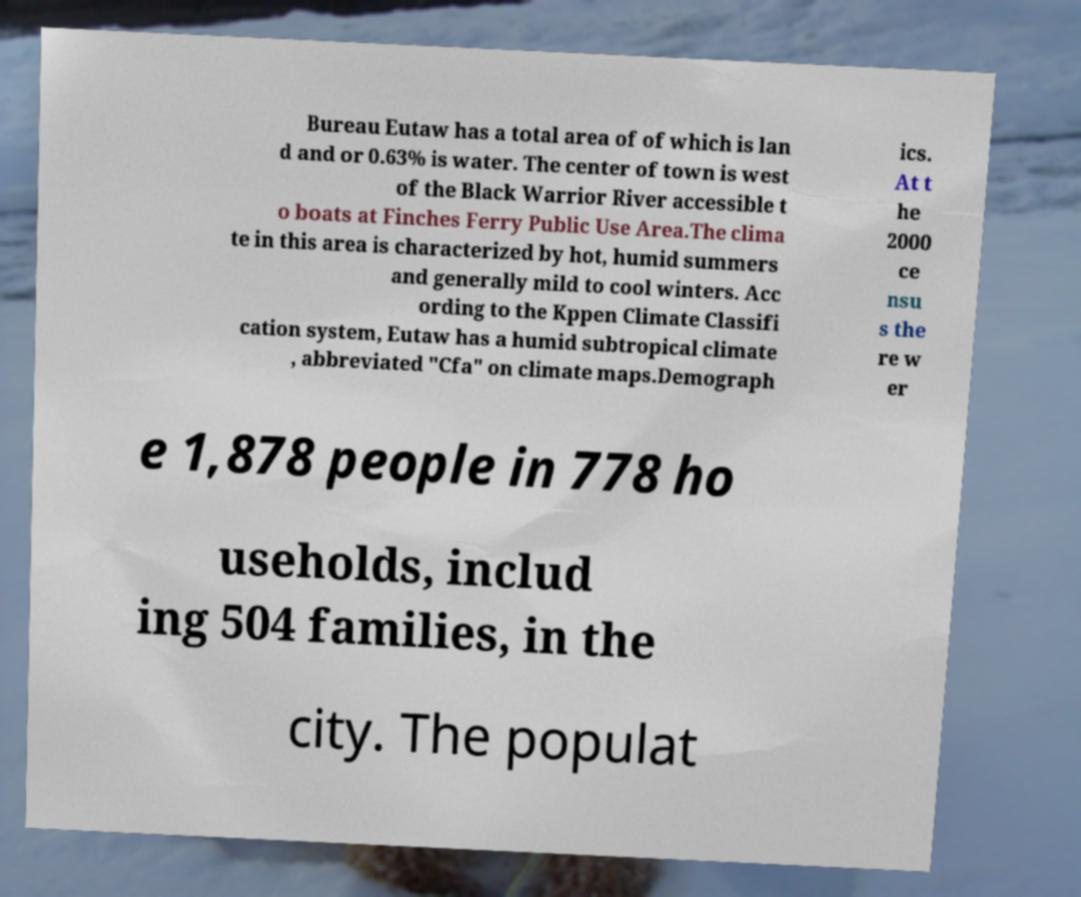There's text embedded in this image that I need extracted. Can you transcribe it verbatim? Bureau Eutaw has a total area of of which is lan d and or 0.63% is water. The center of town is west of the Black Warrior River accessible t o boats at Finches Ferry Public Use Area.The clima te in this area is characterized by hot, humid summers and generally mild to cool winters. Acc ording to the Kppen Climate Classifi cation system, Eutaw has a humid subtropical climate , abbreviated "Cfa" on climate maps.Demograph ics. At t he 2000 ce nsu s the re w er e 1,878 people in 778 ho useholds, includ ing 504 families, in the city. The populat 